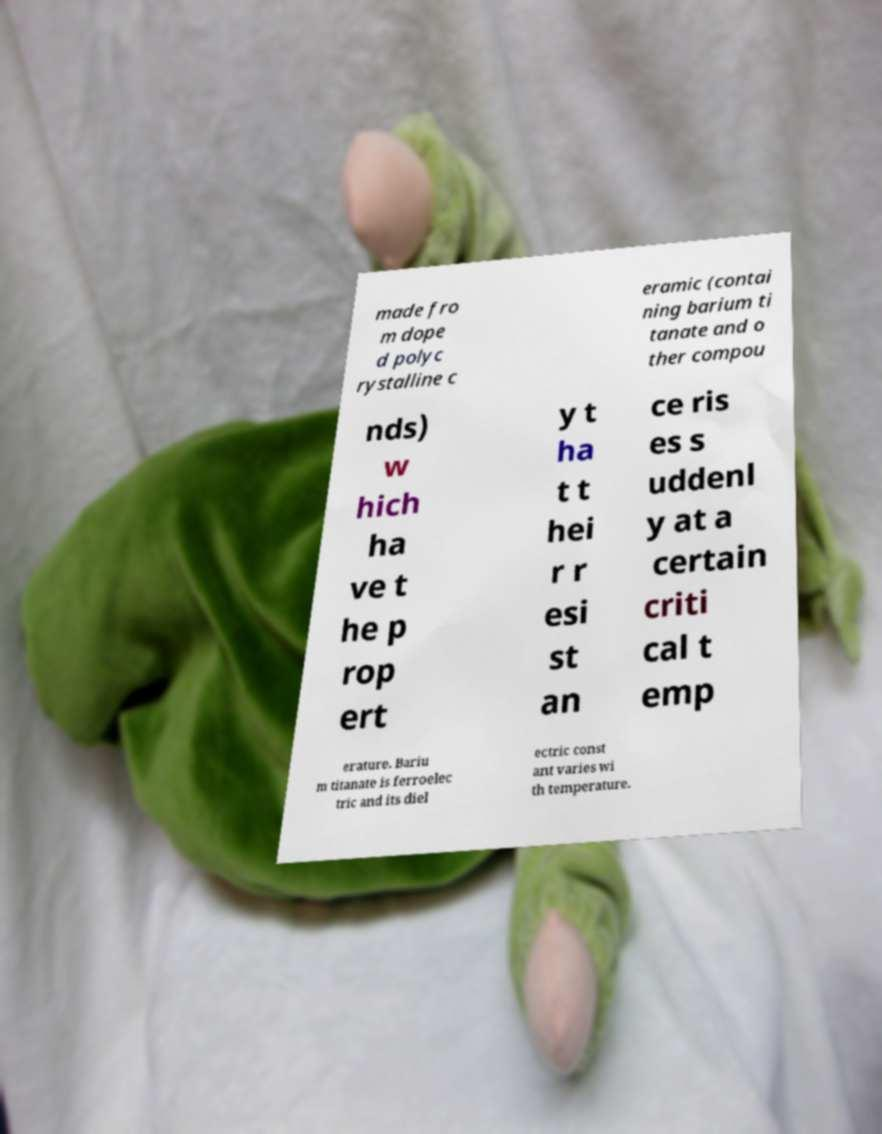What messages or text are displayed in this image? I need them in a readable, typed format. made fro m dope d polyc rystalline c eramic (contai ning barium ti tanate and o ther compou nds) w hich ha ve t he p rop ert y t ha t t hei r r esi st an ce ris es s uddenl y at a certain criti cal t emp erature. Bariu m titanate is ferroelec tric and its diel ectric const ant varies wi th temperature. 